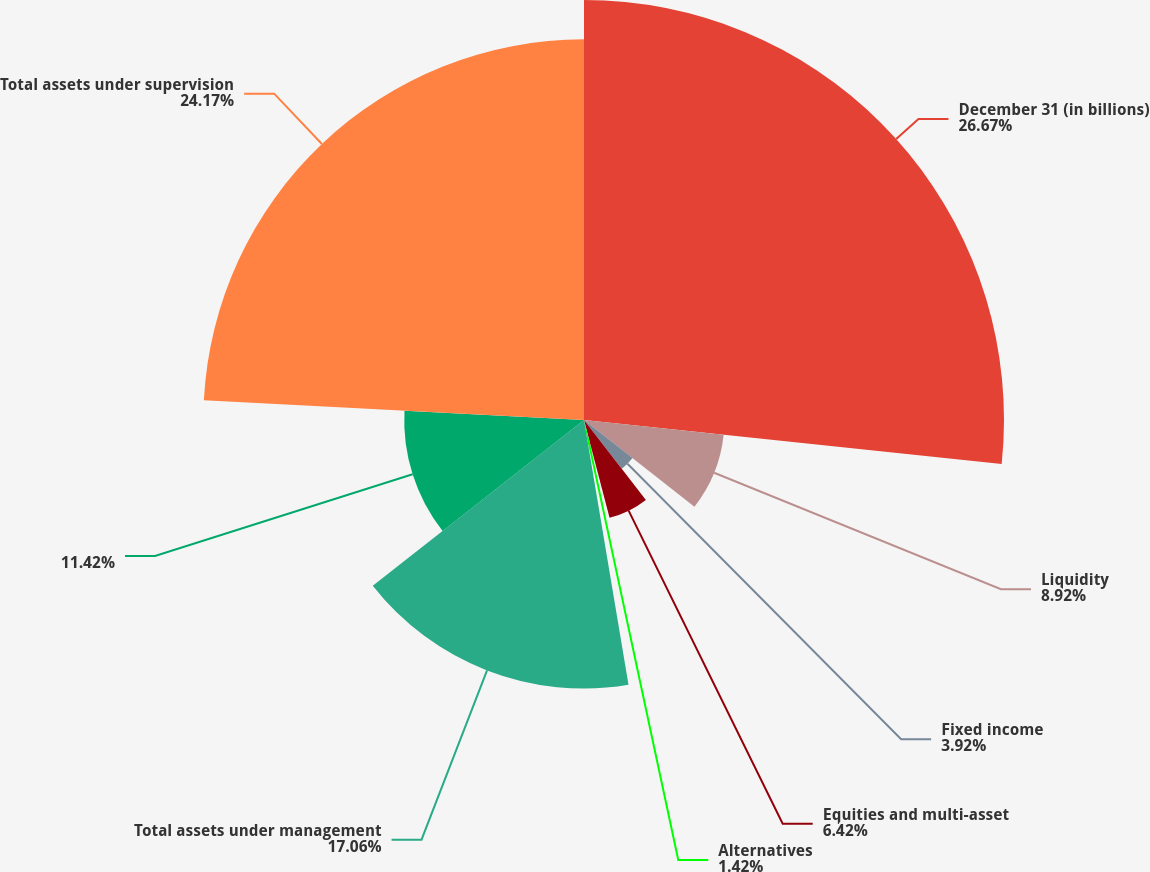<chart> <loc_0><loc_0><loc_500><loc_500><pie_chart><fcel>December 31 (in billions)<fcel>Liquidity<fcel>Fixed income<fcel>Equities and multi-asset<fcel>Alternatives<fcel>Total assets under management<fcel>Unnamed: 6<fcel>Total assets under supervision<nl><fcel>26.68%<fcel>8.92%<fcel>3.92%<fcel>6.42%<fcel>1.42%<fcel>17.06%<fcel>11.42%<fcel>24.18%<nl></chart> 